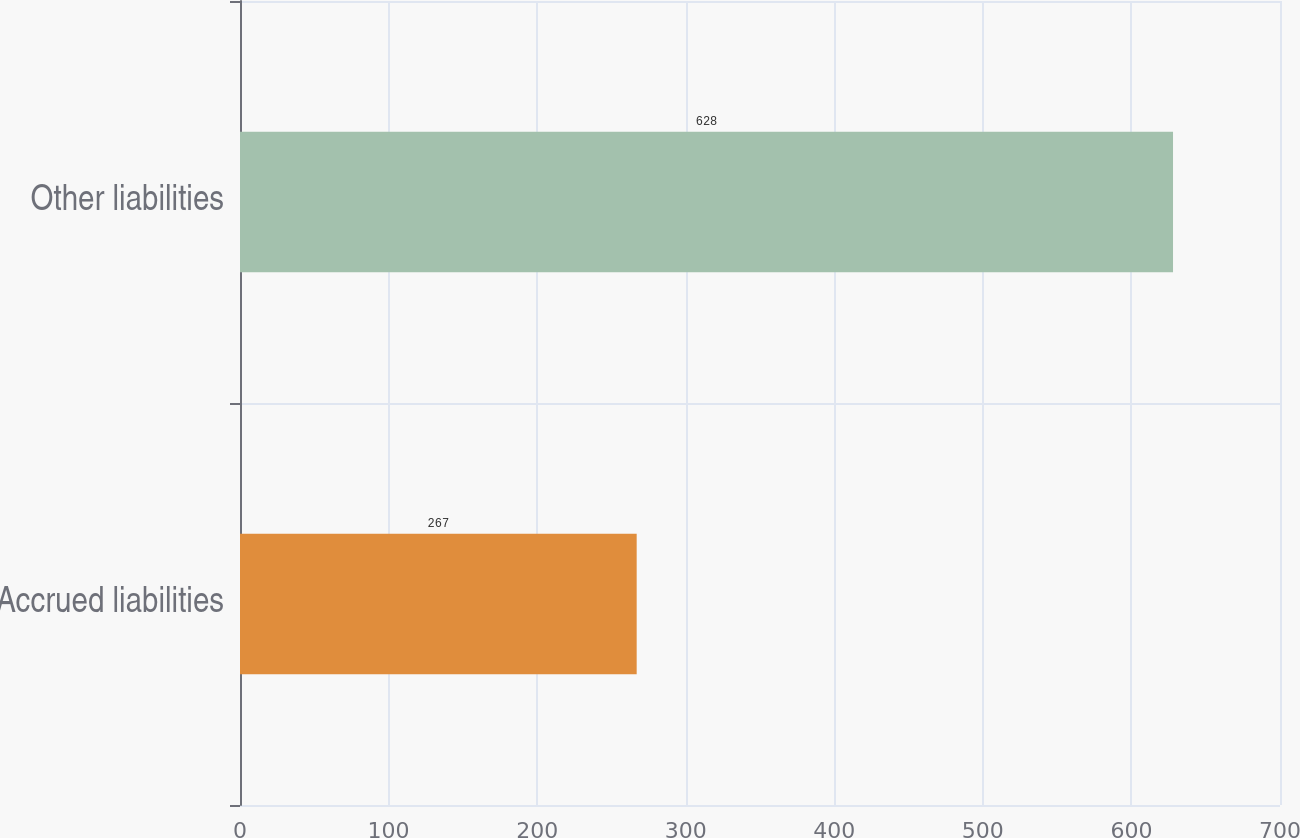Convert chart to OTSL. <chart><loc_0><loc_0><loc_500><loc_500><bar_chart><fcel>Accrued liabilities<fcel>Other liabilities<nl><fcel>267<fcel>628<nl></chart> 